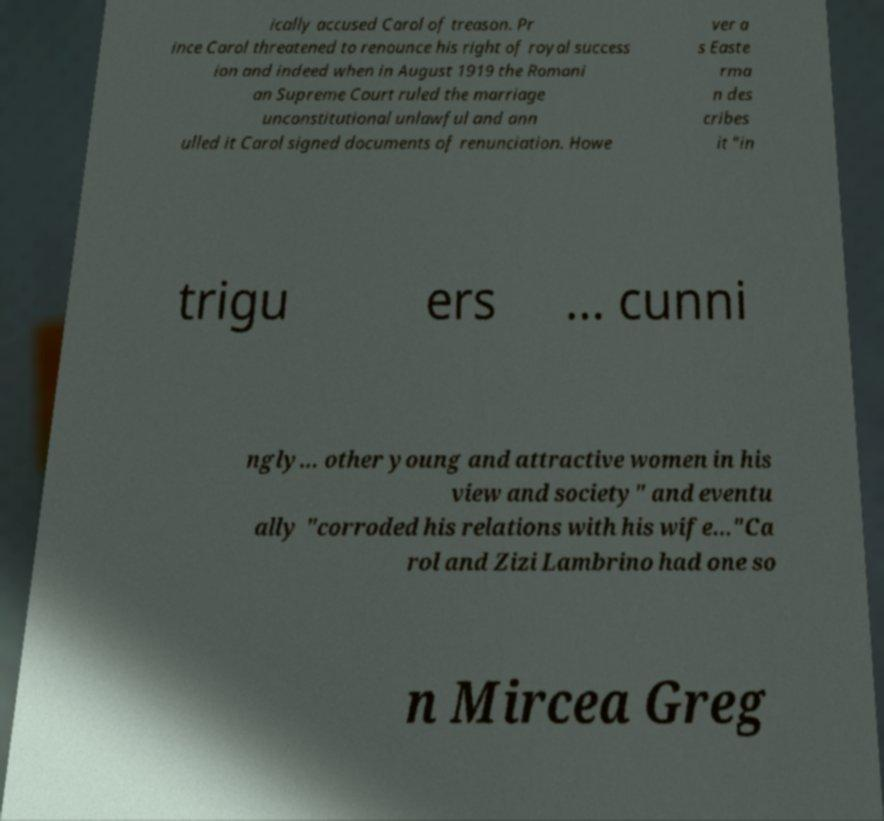For documentation purposes, I need the text within this image transcribed. Could you provide that? ically accused Carol of treason. Pr ince Carol threatened to renounce his right of royal success ion and indeed when in August 1919 the Romani an Supreme Court ruled the marriage unconstitutional unlawful and ann ulled it Carol signed documents of renunciation. Howe ver a s Easte rma n des cribes it "in trigu ers ... cunni ngly... other young and attractive women in his view and society" and eventu ally "corroded his relations with his wife..."Ca rol and Zizi Lambrino had one so n Mircea Greg 